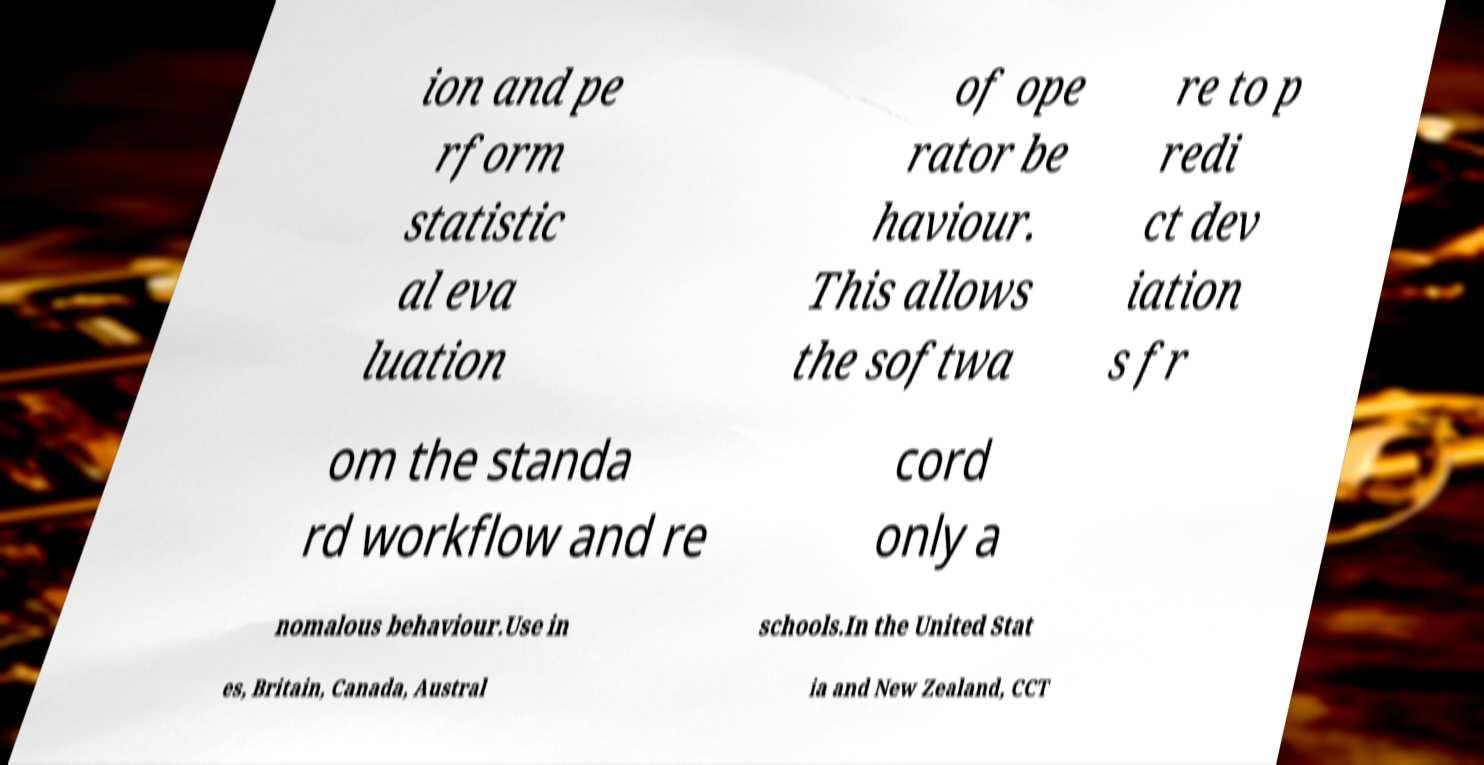Please read and relay the text visible in this image. What does it say? ion and pe rform statistic al eva luation of ope rator be haviour. This allows the softwa re to p redi ct dev iation s fr om the standa rd workflow and re cord only a nomalous behaviour.Use in schools.In the United Stat es, Britain, Canada, Austral ia and New Zealand, CCT 